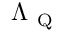Convert formula to latex. <formula><loc_0><loc_0><loc_500><loc_500>\Lambda _ { Q }</formula> 